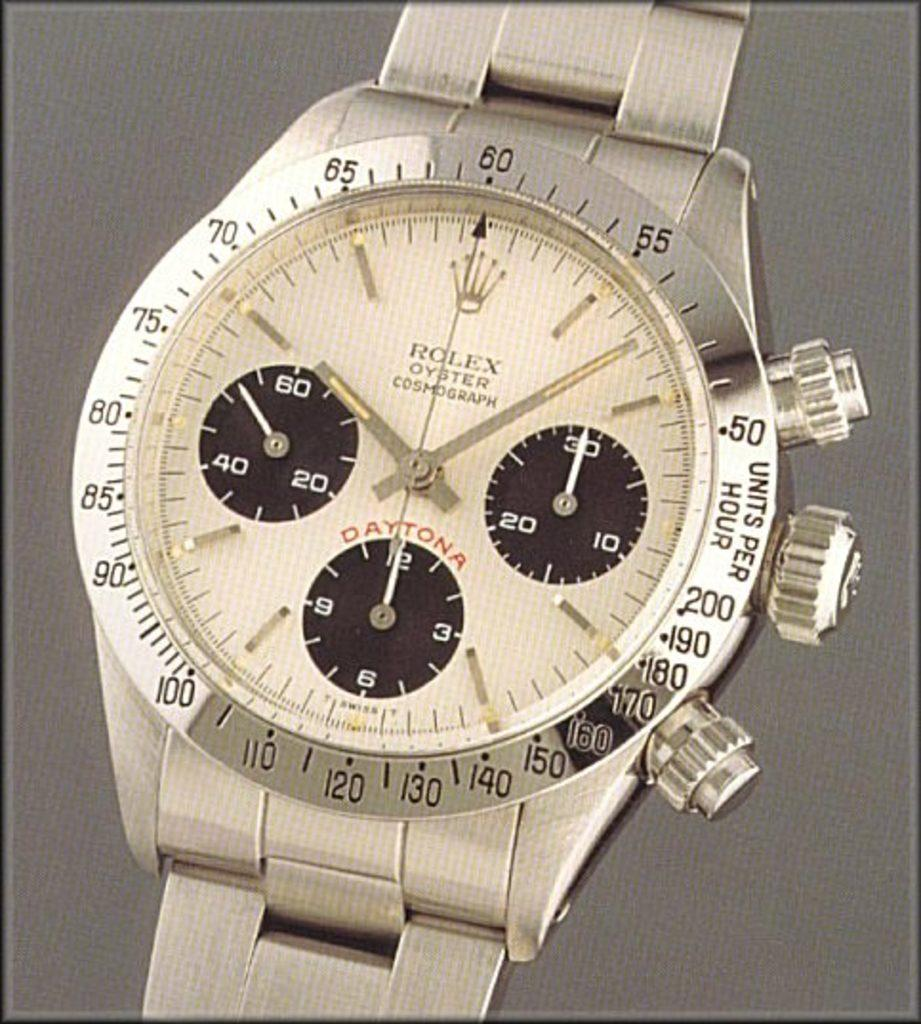<image>
Write a terse but informative summary of the picture. Face of a watch which says DAYTONA on it. 